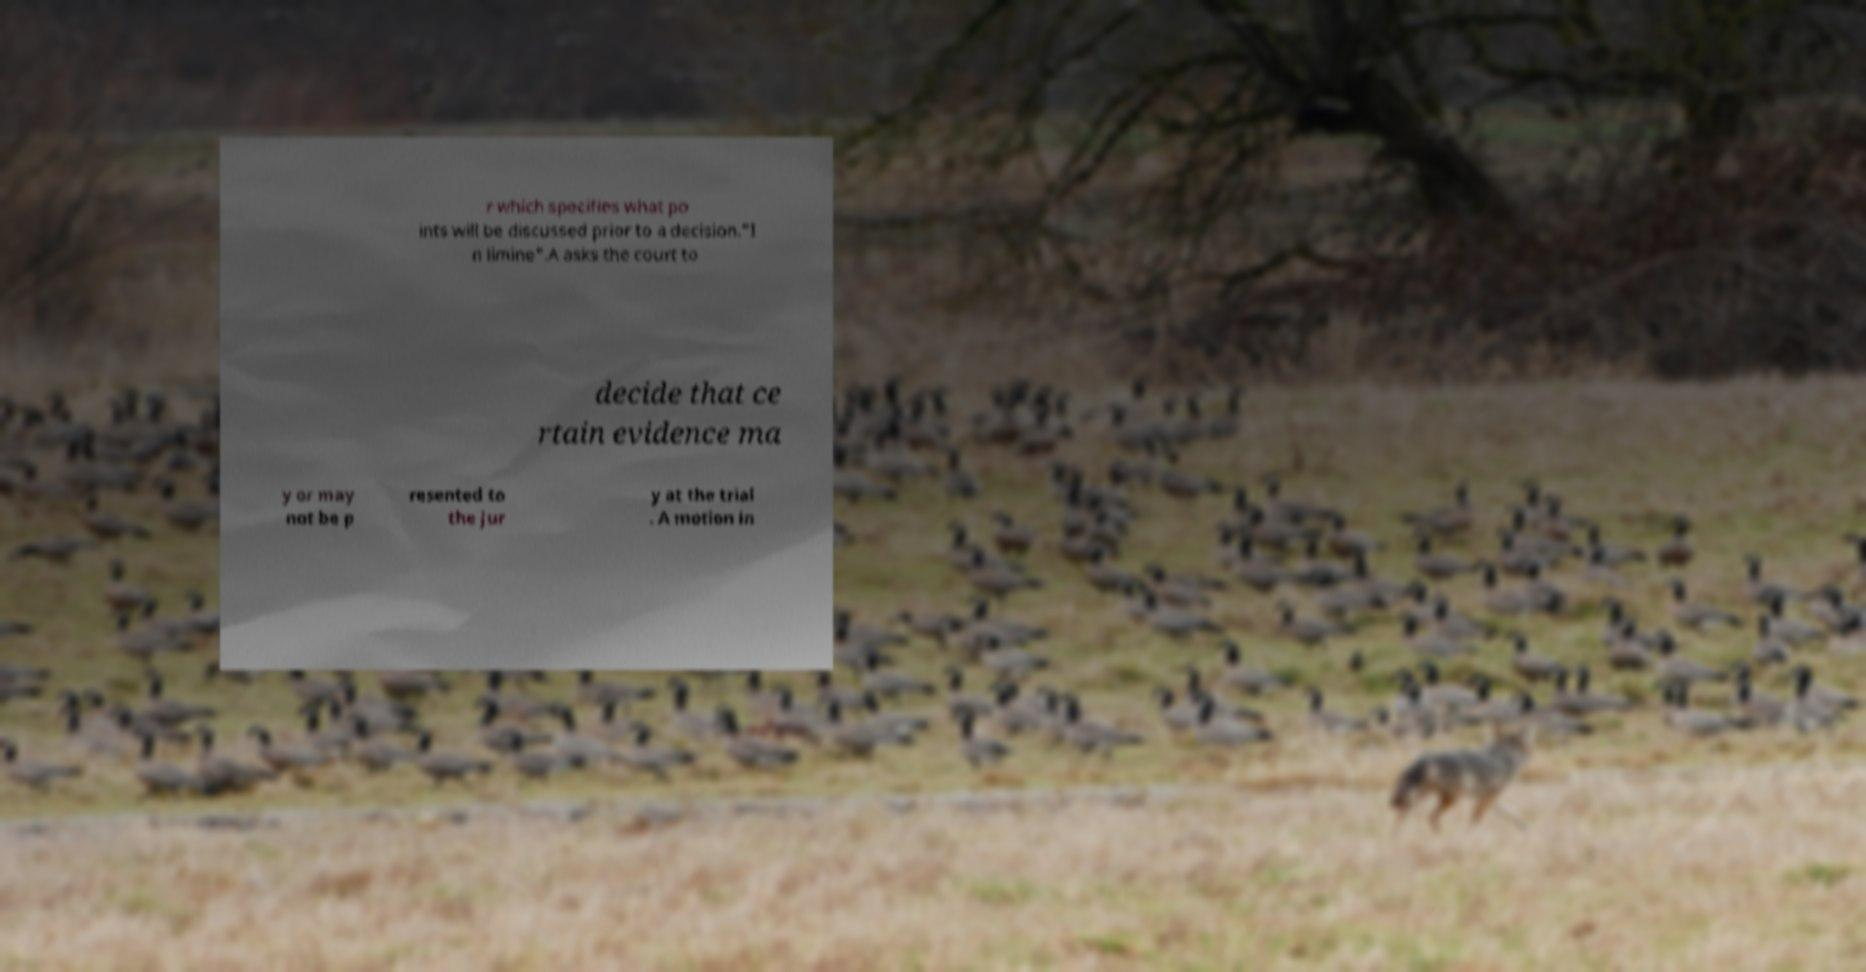There's text embedded in this image that I need extracted. Can you transcribe it verbatim? r which specifies what po ints will be discussed prior to a decision."I n limine".A asks the court to decide that ce rtain evidence ma y or may not be p resented to the jur y at the trial . A motion in 